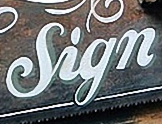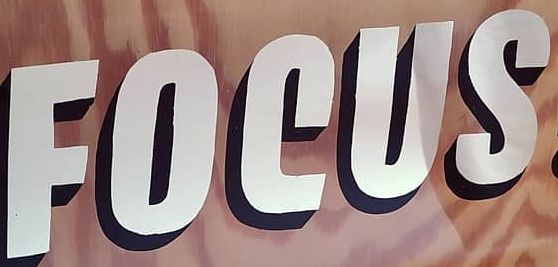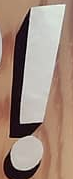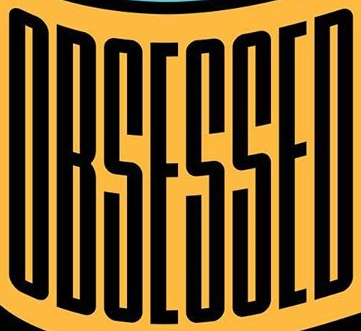Read the text content from these images in order, separated by a semicolon. Sign; FOCUS; !; OBSESSED 